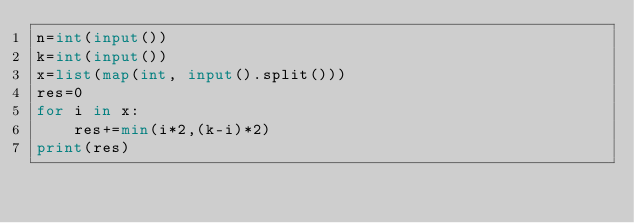Convert code to text. <code><loc_0><loc_0><loc_500><loc_500><_Python_>n=int(input())
k=int(input())
x=list(map(int, input().split()))
res=0
for i in x:
    res+=min(i*2,(k-i)*2)
print(res)</code> 